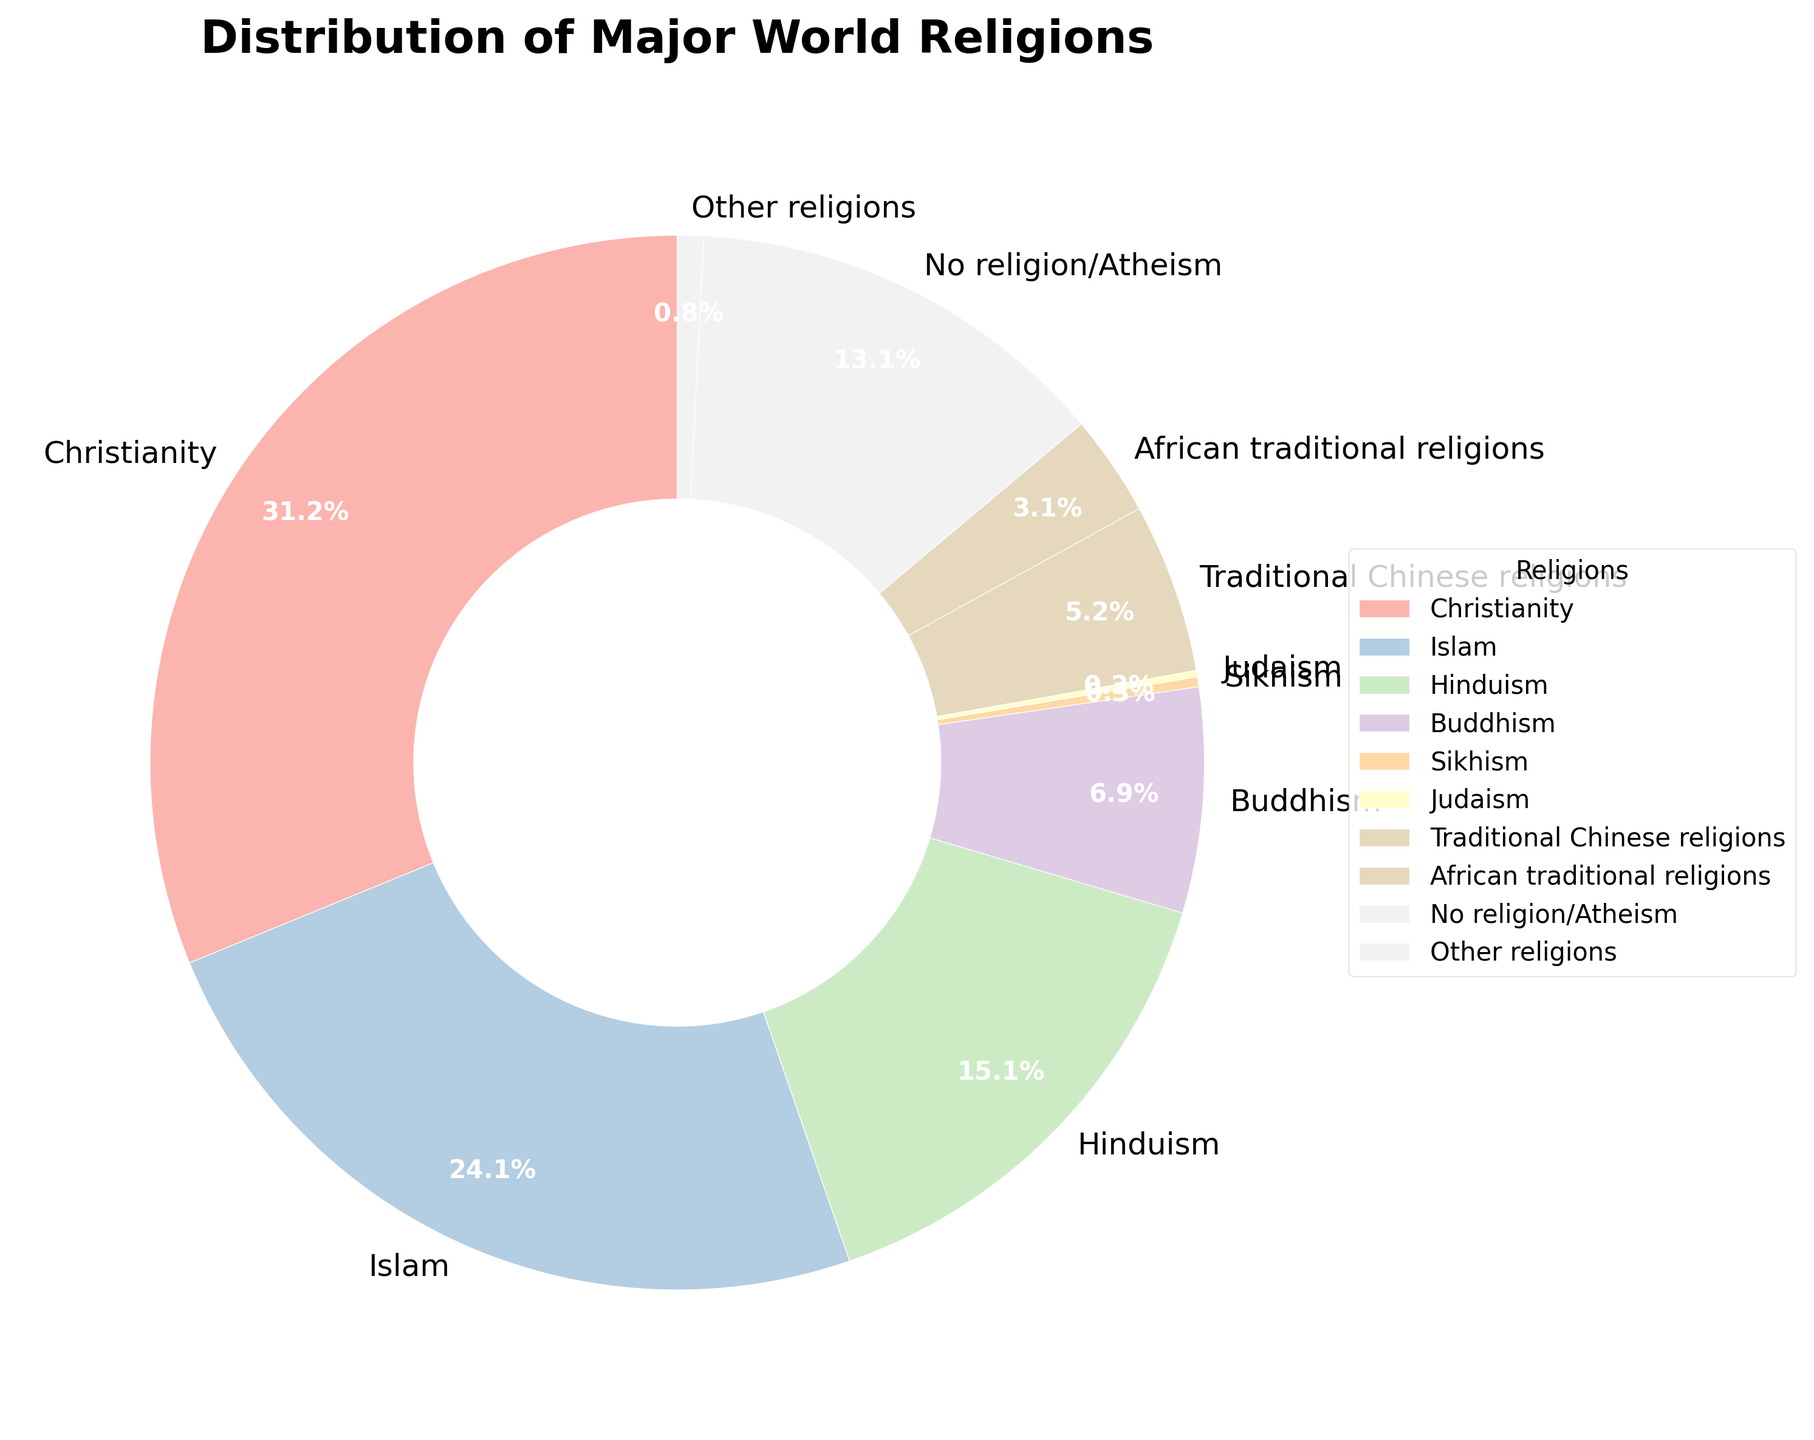Which religion has the highest percentage of followers? To determine this, identify the largest segment in the pie chart. Christianity has the highest percentage of followers at 31.2%.
Answer: Christianity What is the percentage difference between Islam and No religion/Atheism? Subtract the percentage of No religion/Atheism (13.1%) from the percentage of Islam (24.1%) to find the difference. 24.1% - 13.1% = 11%.
Answer: 11% Which religions have less than 1% of the global population? Look at the segments with percentages below 1%. Sikhism (0.3%), Judaism (0.2%), and Other religions (0.8%) all have less than 1% of the global population.
Answer: Sikhism, Judaism, Other religions What is the combined percentage of African traditional religions and Traditional Chinese religions? Add the percentages of African traditional religions (3.1%) and Traditional Chinese religions (5.2%). 3.1% + 5.2% = 8.3%.
Answer: 8.3% Among the major world religions, which one has the lowest percentage of followers? Identify the segment with the smallest percentage. Judaism has the lowest percentage of followers at 0.2%.
Answer: Judaism How does the percentage of Hindus compare to that of Buddhists? Compare the percentages of Hinduism (15.1%) and Buddhism (6.9%). Hinduism has a higher percentage than Buddhism.
Answer: Hinduism If you combine Islam and Christianity, what percentage of the global population do they represent? Add the percentages of Islam (24.1%) and Christianity (31.2%). 24.1% + 31.2% = 55.3%.
Answer: 55.3% Which religions have a larger percentage than Judaism but smaller than Sikhism? Examine the percentages of Judaism (0.2%) and Sikhism (0.3%). There are no religions in the provided data that have percentages larger than 0.2% but smaller than 0.3%.
Answer: None What is the difference in percentage between Buddhism and African traditional religions? Subtract the percentage of African traditional religions (3.1%) from the percentage of Buddhism (6.9%). 6.9% - 3.1% = 3.8%.
Answer: 3.8% Is the percentage of Hindus greater than the combined percentage of Buddhists and No religion/Atheism? Compare the percentage of Hinduism (15.1%) with the sum of Buddhism (6.9%) and No religion/Atheism (13.1%). Add the percentages of Buddhism and No religion/Atheism first: 6.9% + 13.1% = 20%. Since 15.1% < 20%, the percentage of Hindus is not greater.
Answer: No 